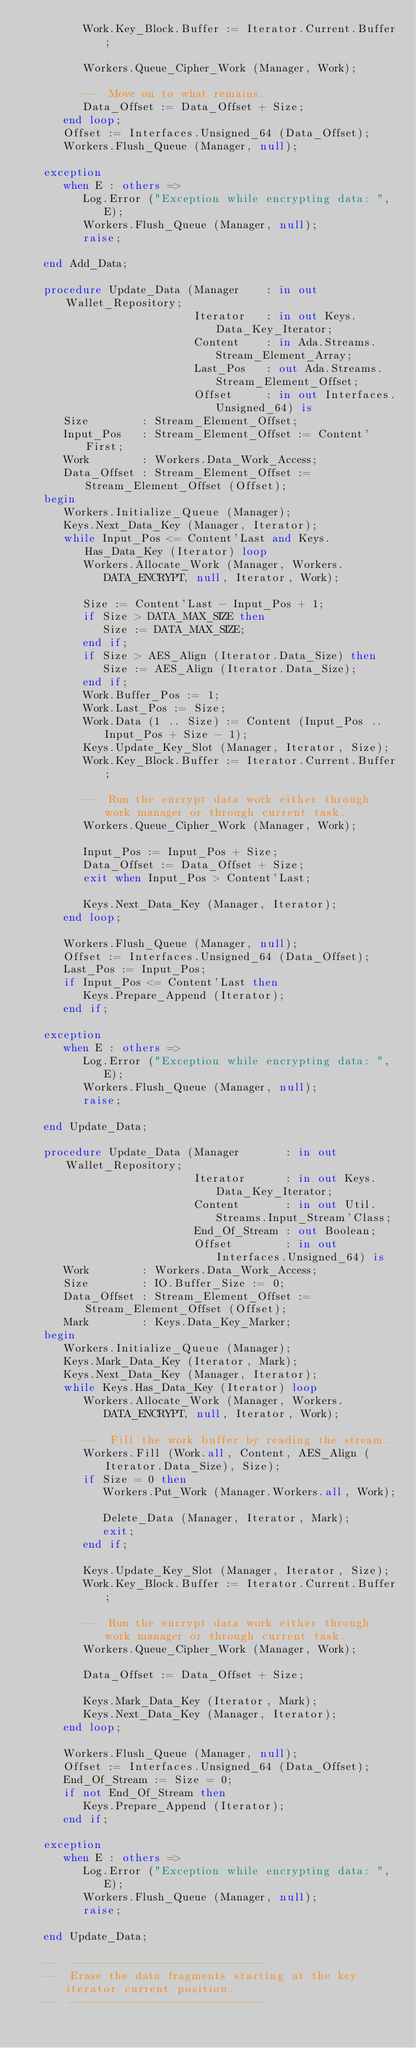Convert code to text. <code><loc_0><loc_0><loc_500><loc_500><_Ada_>         Work.Key_Block.Buffer := Iterator.Current.Buffer;

         Workers.Queue_Cipher_Work (Manager, Work);

         --  Move on to what remains.
         Data_Offset := Data_Offset + Size;
      end loop;
      Offset := Interfaces.Unsigned_64 (Data_Offset);
      Workers.Flush_Queue (Manager, null);

   exception
      when E : others =>
         Log.Error ("Exception while encrypting data: ", E);
         Workers.Flush_Queue (Manager, null);
         raise;

   end Add_Data;

   procedure Update_Data (Manager    : in out Wallet_Repository;
                          Iterator   : in out Keys.Data_Key_Iterator;
                          Content    : in Ada.Streams.Stream_Element_Array;
                          Last_Pos   : out Ada.Streams.Stream_Element_Offset;
                          Offset     : in out Interfaces.Unsigned_64) is
      Size        : Stream_Element_Offset;
      Input_Pos   : Stream_Element_Offset := Content'First;
      Work        : Workers.Data_Work_Access;
      Data_Offset : Stream_Element_Offset := Stream_Element_Offset (Offset);
   begin
      Workers.Initialize_Queue (Manager);
      Keys.Next_Data_Key (Manager, Iterator);
      while Input_Pos <= Content'Last and Keys.Has_Data_Key (Iterator) loop
         Workers.Allocate_Work (Manager, Workers.DATA_ENCRYPT, null, Iterator, Work);

         Size := Content'Last - Input_Pos + 1;
         if Size > DATA_MAX_SIZE then
            Size := DATA_MAX_SIZE;
         end if;
         if Size > AES_Align (Iterator.Data_Size) then
            Size := AES_Align (Iterator.Data_Size);
         end if;
         Work.Buffer_Pos := 1;
         Work.Last_Pos := Size;
         Work.Data (1 .. Size) := Content (Input_Pos .. Input_Pos + Size - 1);
         Keys.Update_Key_Slot (Manager, Iterator, Size);
         Work.Key_Block.Buffer := Iterator.Current.Buffer;

         --  Run the encrypt data work either through work manager or through current task.
         Workers.Queue_Cipher_Work (Manager, Work);

         Input_Pos := Input_Pos + Size;
         Data_Offset := Data_Offset + Size;
         exit when Input_Pos > Content'Last;

         Keys.Next_Data_Key (Manager, Iterator);
      end loop;

      Workers.Flush_Queue (Manager, null);
      Offset := Interfaces.Unsigned_64 (Data_Offset);
      Last_Pos := Input_Pos;
      if Input_Pos <= Content'Last then
         Keys.Prepare_Append (Iterator);
      end if;

   exception
      when E : others =>
         Log.Error ("Exception while encrypting data: ", E);
         Workers.Flush_Queue (Manager, null);
         raise;

   end Update_Data;

   procedure Update_Data (Manager       : in out Wallet_Repository;
                          Iterator      : in out Keys.Data_Key_Iterator;
                          Content       : in out Util.Streams.Input_Stream'Class;
                          End_Of_Stream : out Boolean;
                          Offset        : in out Interfaces.Unsigned_64) is
      Work        : Workers.Data_Work_Access;
      Size        : IO.Buffer_Size := 0;
      Data_Offset : Stream_Element_Offset := Stream_Element_Offset (Offset);
      Mark        : Keys.Data_Key_Marker;
   begin
      Workers.Initialize_Queue (Manager);
      Keys.Mark_Data_Key (Iterator, Mark);
      Keys.Next_Data_Key (Manager, Iterator);
      while Keys.Has_Data_Key (Iterator) loop
         Workers.Allocate_Work (Manager, Workers.DATA_ENCRYPT, null, Iterator, Work);

         --  Fill the work buffer by reading the stream.
         Workers.Fill (Work.all, Content, AES_Align (Iterator.Data_Size), Size);
         if Size = 0 then
            Workers.Put_Work (Manager.Workers.all, Work);

            Delete_Data (Manager, Iterator, Mark);
            exit;
         end if;

         Keys.Update_Key_Slot (Manager, Iterator, Size);
         Work.Key_Block.Buffer := Iterator.Current.Buffer;

         --  Run the encrypt data work either through work manager or through current task.
         Workers.Queue_Cipher_Work (Manager, Work);

         Data_Offset := Data_Offset + Size;

         Keys.Mark_Data_Key (Iterator, Mark);
         Keys.Next_Data_Key (Manager, Iterator);
      end loop;

      Workers.Flush_Queue (Manager, null);
      Offset := Interfaces.Unsigned_64 (Data_Offset);
      End_Of_Stream := Size = 0;
      if not End_Of_Stream then
         Keys.Prepare_Append (Iterator);
      end if;

   exception
      when E : others =>
         Log.Error ("Exception while encrypting data: ", E);
         Workers.Flush_Queue (Manager, null);
         raise;

   end Update_Data;

   --  ------------------------------
   --  Erase the data fragments starting at the key iterator current position.
   --  ------------------------------</code> 